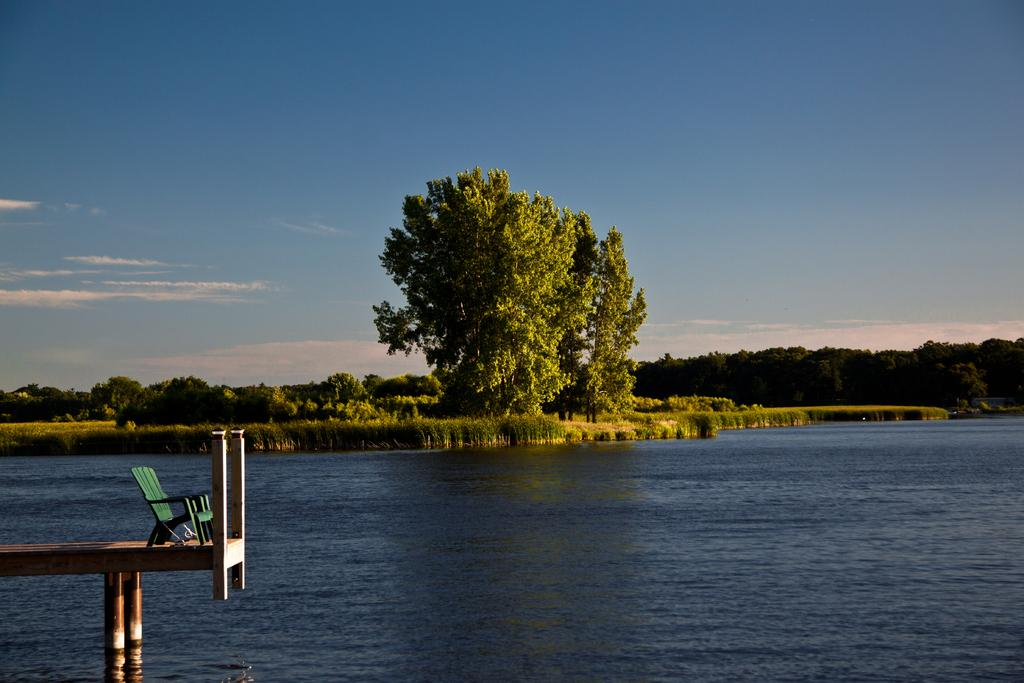What is one of the main elements in the image? There is water in the image. What type of vegetation can be seen in the image? There are trees and plants in the image. Where is the chair located in the image? The chair is on a pathway at the bottom left side of the image. What can be seen in the background of the image? The sky is visible in the background of the image. What color is the hat worn by the person standing on the bridge in the image? There is no person wearing a hat on a bridge in the image, as there is no bridge present. 